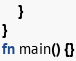<code> <loc_0><loc_0><loc_500><loc_500><_Rust_>    }
}
fn main() {}
</code> 